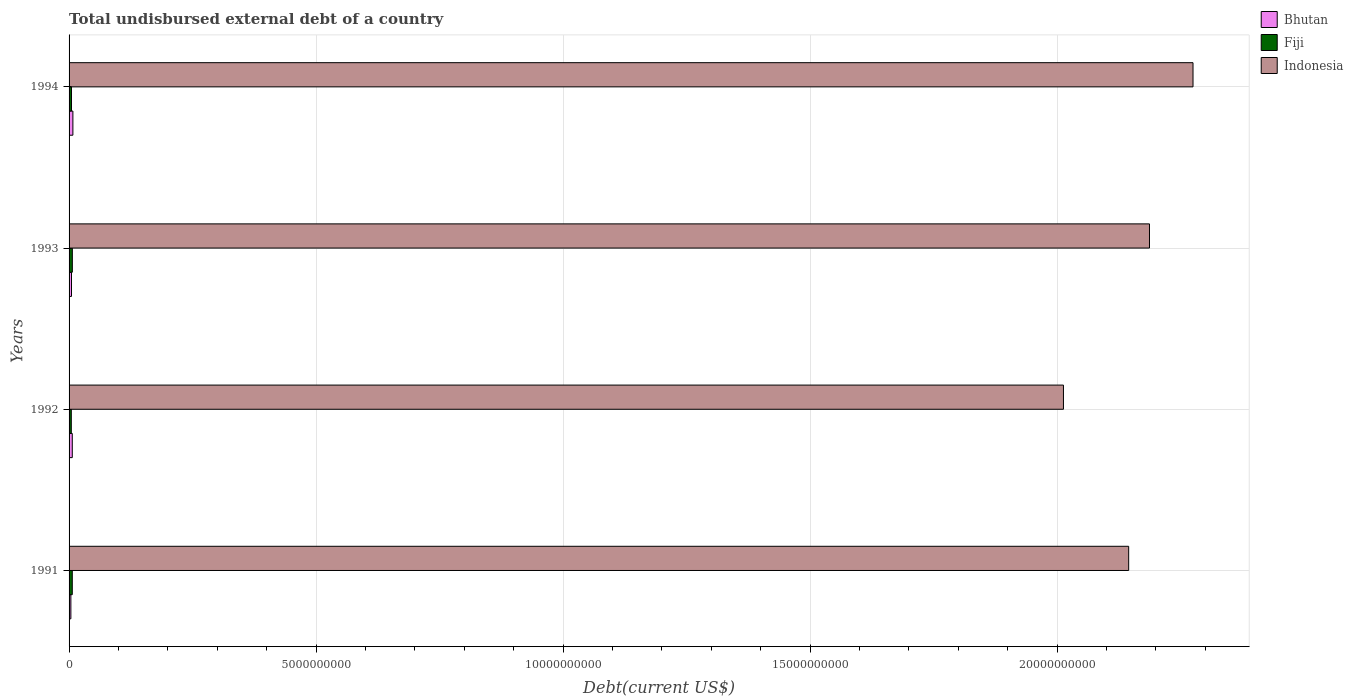How many groups of bars are there?
Give a very brief answer. 4. Are the number of bars on each tick of the Y-axis equal?
Offer a terse response. Yes. How many bars are there on the 4th tick from the top?
Your answer should be very brief. 3. In how many cases, is the number of bars for a given year not equal to the number of legend labels?
Give a very brief answer. 0. What is the total undisbursed external debt in Bhutan in 1992?
Provide a short and direct response. 6.49e+07. Across all years, what is the maximum total undisbursed external debt in Indonesia?
Provide a short and direct response. 2.28e+1. Across all years, what is the minimum total undisbursed external debt in Bhutan?
Make the answer very short. 3.65e+07. In which year was the total undisbursed external debt in Bhutan maximum?
Keep it short and to the point. 1994. What is the total total undisbursed external debt in Indonesia in the graph?
Give a very brief answer. 8.62e+1. What is the difference between the total undisbursed external debt in Bhutan in 1991 and that in 1992?
Your response must be concise. -2.84e+07. What is the difference between the total undisbursed external debt in Bhutan in 1994 and the total undisbursed external debt in Indonesia in 1992?
Your response must be concise. -2.01e+1. What is the average total undisbursed external debt in Indonesia per year?
Provide a succinct answer. 2.16e+1. In the year 1993, what is the difference between the total undisbursed external debt in Fiji and total undisbursed external debt in Bhutan?
Make the answer very short. 1.69e+07. What is the ratio of the total undisbursed external debt in Fiji in 1992 to that in 1994?
Provide a succinct answer. 0.93. Is the difference between the total undisbursed external debt in Fiji in 1991 and 1993 greater than the difference between the total undisbursed external debt in Bhutan in 1991 and 1993?
Provide a short and direct response. Yes. What is the difference between the highest and the second highest total undisbursed external debt in Bhutan?
Your answer should be very brief. 1.25e+07. What is the difference between the highest and the lowest total undisbursed external debt in Bhutan?
Offer a very short reply. 4.09e+07. What does the 3rd bar from the top in 1994 represents?
Your response must be concise. Bhutan. What does the 3rd bar from the bottom in 1992 represents?
Your response must be concise. Indonesia. Is it the case that in every year, the sum of the total undisbursed external debt in Bhutan and total undisbursed external debt in Fiji is greater than the total undisbursed external debt in Indonesia?
Ensure brevity in your answer.  No. Are the values on the major ticks of X-axis written in scientific E-notation?
Keep it short and to the point. No. Does the graph contain any zero values?
Provide a short and direct response. No. Does the graph contain grids?
Provide a succinct answer. Yes. Where does the legend appear in the graph?
Your response must be concise. Top right. How are the legend labels stacked?
Offer a terse response. Vertical. What is the title of the graph?
Keep it short and to the point. Total undisbursed external debt of a country. What is the label or title of the X-axis?
Provide a short and direct response. Debt(current US$). What is the Debt(current US$) of Bhutan in 1991?
Ensure brevity in your answer.  3.65e+07. What is the Debt(current US$) of Fiji in 1991?
Make the answer very short. 6.49e+07. What is the Debt(current US$) of Indonesia in 1991?
Provide a short and direct response. 2.14e+1. What is the Debt(current US$) of Bhutan in 1992?
Your answer should be compact. 6.49e+07. What is the Debt(current US$) in Fiji in 1992?
Make the answer very short. 4.52e+07. What is the Debt(current US$) of Indonesia in 1992?
Your answer should be compact. 2.01e+1. What is the Debt(current US$) in Bhutan in 1993?
Your answer should be very brief. 4.93e+07. What is the Debt(current US$) in Fiji in 1993?
Offer a terse response. 6.62e+07. What is the Debt(current US$) in Indonesia in 1993?
Give a very brief answer. 2.19e+1. What is the Debt(current US$) of Bhutan in 1994?
Your answer should be compact. 7.74e+07. What is the Debt(current US$) in Fiji in 1994?
Your answer should be compact. 4.88e+07. What is the Debt(current US$) in Indonesia in 1994?
Give a very brief answer. 2.28e+1. Across all years, what is the maximum Debt(current US$) of Bhutan?
Your answer should be compact. 7.74e+07. Across all years, what is the maximum Debt(current US$) in Fiji?
Offer a terse response. 6.62e+07. Across all years, what is the maximum Debt(current US$) of Indonesia?
Keep it short and to the point. 2.28e+1. Across all years, what is the minimum Debt(current US$) in Bhutan?
Offer a very short reply. 3.65e+07. Across all years, what is the minimum Debt(current US$) in Fiji?
Your response must be concise. 4.52e+07. Across all years, what is the minimum Debt(current US$) in Indonesia?
Your response must be concise. 2.01e+1. What is the total Debt(current US$) in Bhutan in the graph?
Offer a very short reply. 2.28e+08. What is the total Debt(current US$) in Fiji in the graph?
Give a very brief answer. 2.25e+08. What is the total Debt(current US$) of Indonesia in the graph?
Your answer should be compact. 8.62e+1. What is the difference between the Debt(current US$) of Bhutan in 1991 and that in 1992?
Provide a succinct answer. -2.84e+07. What is the difference between the Debt(current US$) of Fiji in 1991 and that in 1992?
Keep it short and to the point. 1.98e+07. What is the difference between the Debt(current US$) in Indonesia in 1991 and that in 1992?
Ensure brevity in your answer.  1.32e+09. What is the difference between the Debt(current US$) in Bhutan in 1991 and that in 1993?
Your answer should be compact. -1.27e+07. What is the difference between the Debt(current US$) in Fiji in 1991 and that in 1993?
Your answer should be compact. -1.23e+06. What is the difference between the Debt(current US$) in Indonesia in 1991 and that in 1993?
Ensure brevity in your answer.  -4.21e+08. What is the difference between the Debt(current US$) in Bhutan in 1991 and that in 1994?
Provide a short and direct response. -4.09e+07. What is the difference between the Debt(current US$) of Fiji in 1991 and that in 1994?
Make the answer very short. 1.61e+07. What is the difference between the Debt(current US$) of Indonesia in 1991 and that in 1994?
Offer a terse response. -1.30e+09. What is the difference between the Debt(current US$) of Bhutan in 1992 and that in 1993?
Make the answer very short. 1.56e+07. What is the difference between the Debt(current US$) of Fiji in 1992 and that in 1993?
Offer a terse response. -2.10e+07. What is the difference between the Debt(current US$) of Indonesia in 1992 and that in 1993?
Offer a terse response. -1.74e+09. What is the difference between the Debt(current US$) in Bhutan in 1992 and that in 1994?
Provide a succinct answer. -1.25e+07. What is the difference between the Debt(current US$) in Fiji in 1992 and that in 1994?
Your answer should be very brief. -3.61e+06. What is the difference between the Debt(current US$) of Indonesia in 1992 and that in 1994?
Your answer should be compact. -2.62e+09. What is the difference between the Debt(current US$) of Bhutan in 1993 and that in 1994?
Make the answer very short. -2.82e+07. What is the difference between the Debt(current US$) in Fiji in 1993 and that in 1994?
Offer a terse response. 1.74e+07. What is the difference between the Debt(current US$) in Indonesia in 1993 and that in 1994?
Provide a short and direct response. -8.81e+08. What is the difference between the Debt(current US$) in Bhutan in 1991 and the Debt(current US$) in Fiji in 1992?
Offer a terse response. -8.66e+06. What is the difference between the Debt(current US$) in Bhutan in 1991 and the Debt(current US$) in Indonesia in 1992?
Provide a short and direct response. -2.01e+1. What is the difference between the Debt(current US$) in Fiji in 1991 and the Debt(current US$) in Indonesia in 1992?
Give a very brief answer. -2.01e+1. What is the difference between the Debt(current US$) of Bhutan in 1991 and the Debt(current US$) of Fiji in 1993?
Ensure brevity in your answer.  -2.96e+07. What is the difference between the Debt(current US$) of Bhutan in 1991 and the Debt(current US$) of Indonesia in 1993?
Keep it short and to the point. -2.18e+1. What is the difference between the Debt(current US$) in Fiji in 1991 and the Debt(current US$) in Indonesia in 1993?
Keep it short and to the point. -2.18e+1. What is the difference between the Debt(current US$) of Bhutan in 1991 and the Debt(current US$) of Fiji in 1994?
Your answer should be compact. -1.23e+07. What is the difference between the Debt(current US$) in Bhutan in 1991 and the Debt(current US$) in Indonesia in 1994?
Keep it short and to the point. -2.27e+1. What is the difference between the Debt(current US$) of Fiji in 1991 and the Debt(current US$) of Indonesia in 1994?
Give a very brief answer. -2.27e+1. What is the difference between the Debt(current US$) of Bhutan in 1992 and the Debt(current US$) of Fiji in 1993?
Provide a succinct answer. -1.27e+06. What is the difference between the Debt(current US$) in Bhutan in 1992 and the Debt(current US$) in Indonesia in 1993?
Your answer should be compact. -2.18e+1. What is the difference between the Debt(current US$) of Fiji in 1992 and the Debt(current US$) of Indonesia in 1993?
Ensure brevity in your answer.  -2.18e+1. What is the difference between the Debt(current US$) in Bhutan in 1992 and the Debt(current US$) in Fiji in 1994?
Your response must be concise. 1.61e+07. What is the difference between the Debt(current US$) in Bhutan in 1992 and the Debt(current US$) in Indonesia in 1994?
Your response must be concise. -2.27e+1. What is the difference between the Debt(current US$) of Fiji in 1992 and the Debt(current US$) of Indonesia in 1994?
Offer a terse response. -2.27e+1. What is the difference between the Debt(current US$) in Bhutan in 1993 and the Debt(current US$) in Fiji in 1994?
Provide a short and direct response. 4.79e+05. What is the difference between the Debt(current US$) in Bhutan in 1993 and the Debt(current US$) in Indonesia in 1994?
Provide a succinct answer. -2.27e+1. What is the difference between the Debt(current US$) of Fiji in 1993 and the Debt(current US$) of Indonesia in 1994?
Ensure brevity in your answer.  -2.27e+1. What is the average Debt(current US$) of Bhutan per year?
Provide a succinct answer. 5.70e+07. What is the average Debt(current US$) of Fiji per year?
Provide a short and direct response. 5.63e+07. What is the average Debt(current US$) in Indonesia per year?
Your answer should be very brief. 2.16e+1. In the year 1991, what is the difference between the Debt(current US$) of Bhutan and Debt(current US$) of Fiji?
Provide a short and direct response. -2.84e+07. In the year 1991, what is the difference between the Debt(current US$) of Bhutan and Debt(current US$) of Indonesia?
Keep it short and to the point. -2.14e+1. In the year 1991, what is the difference between the Debt(current US$) in Fiji and Debt(current US$) in Indonesia?
Ensure brevity in your answer.  -2.14e+1. In the year 1992, what is the difference between the Debt(current US$) in Bhutan and Debt(current US$) in Fiji?
Offer a very short reply. 1.97e+07. In the year 1992, what is the difference between the Debt(current US$) in Bhutan and Debt(current US$) in Indonesia?
Provide a short and direct response. -2.01e+1. In the year 1992, what is the difference between the Debt(current US$) of Fiji and Debt(current US$) of Indonesia?
Keep it short and to the point. -2.01e+1. In the year 1993, what is the difference between the Debt(current US$) of Bhutan and Debt(current US$) of Fiji?
Your answer should be very brief. -1.69e+07. In the year 1993, what is the difference between the Debt(current US$) in Bhutan and Debt(current US$) in Indonesia?
Offer a very short reply. -2.18e+1. In the year 1993, what is the difference between the Debt(current US$) in Fiji and Debt(current US$) in Indonesia?
Offer a terse response. -2.18e+1. In the year 1994, what is the difference between the Debt(current US$) in Bhutan and Debt(current US$) in Fiji?
Your response must be concise. 2.86e+07. In the year 1994, what is the difference between the Debt(current US$) of Bhutan and Debt(current US$) of Indonesia?
Provide a succinct answer. -2.27e+1. In the year 1994, what is the difference between the Debt(current US$) in Fiji and Debt(current US$) in Indonesia?
Your response must be concise. -2.27e+1. What is the ratio of the Debt(current US$) of Bhutan in 1991 to that in 1992?
Provide a short and direct response. 0.56. What is the ratio of the Debt(current US$) in Fiji in 1991 to that in 1992?
Your answer should be very brief. 1.44. What is the ratio of the Debt(current US$) of Indonesia in 1991 to that in 1992?
Your answer should be very brief. 1.07. What is the ratio of the Debt(current US$) of Bhutan in 1991 to that in 1993?
Provide a succinct answer. 0.74. What is the ratio of the Debt(current US$) in Fiji in 1991 to that in 1993?
Give a very brief answer. 0.98. What is the ratio of the Debt(current US$) in Indonesia in 1991 to that in 1993?
Offer a terse response. 0.98. What is the ratio of the Debt(current US$) in Bhutan in 1991 to that in 1994?
Provide a short and direct response. 0.47. What is the ratio of the Debt(current US$) in Fiji in 1991 to that in 1994?
Ensure brevity in your answer.  1.33. What is the ratio of the Debt(current US$) of Indonesia in 1991 to that in 1994?
Your response must be concise. 0.94. What is the ratio of the Debt(current US$) of Bhutan in 1992 to that in 1993?
Your answer should be compact. 1.32. What is the ratio of the Debt(current US$) of Fiji in 1992 to that in 1993?
Keep it short and to the point. 0.68. What is the ratio of the Debt(current US$) of Indonesia in 1992 to that in 1993?
Offer a very short reply. 0.92. What is the ratio of the Debt(current US$) in Bhutan in 1992 to that in 1994?
Your response must be concise. 0.84. What is the ratio of the Debt(current US$) of Fiji in 1992 to that in 1994?
Make the answer very short. 0.93. What is the ratio of the Debt(current US$) in Indonesia in 1992 to that in 1994?
Give a very brief answer. 0.88. What is the ratio of the Debt(current US$) of Bhutan in 1993 to that in 1994?
Give a very brief answer. 0.64. What is the ratio of the Debt(current US$) of Fiji in 1993 to that in 1994?
Your response must be concise. 1.36. What is the ratio of the Debt(current US$) in Indonesia in 1993 to that in 1994?
Provide a short and direct response. 0.96. What is the difference between the highest and the second highest Debt(current US$) in Bhutan?
Provide a succinct answer. 1.25e+07. What is the difference between the highest and the second highest Debt(current US$) of Fiji?
Your answer should be compact. 1.23e+06. What is the difference between the highest and the second highest Debt(current US$) in Indonesia?
Make the answer very short. 8.81e+08. What is the difference between the highest and the lowest Debt(current US$) in Bhutan?
Your answer should be very brief. 4.09e+07. What is the difference between the highest and the lowest Debt(current US$) of Fiji?
Give a very brief answer. 2.10e+07. What is the difference between the highest and the lowest Debt(current US$) of Indonesia?
Make the answer very short. 2.62e+09. 